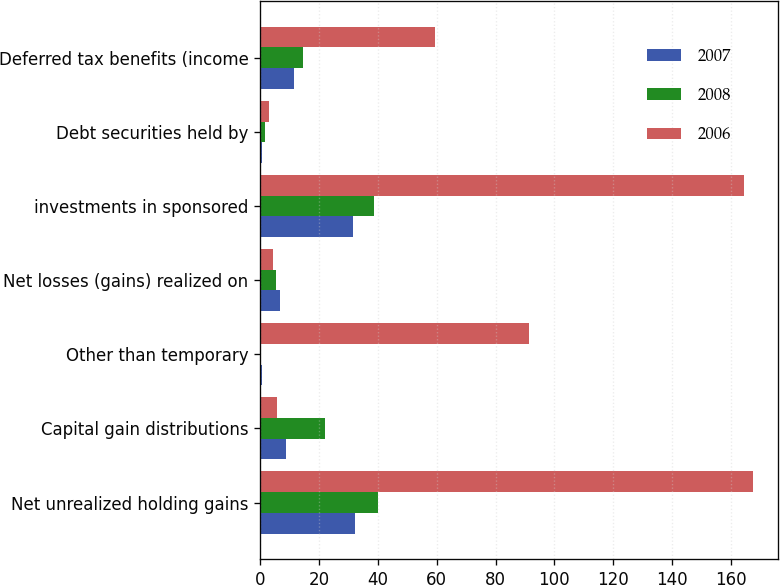Convert chart. <chart><loc_0><loc_0><loc_500><loc_500><stacked_bar_chart><ecel><fcel>Net unrealized holding gains<fcel>Capital gain distributions<fcel>Other than temporary<fcel>Net losses (gains) realized on<fcel>investments in sponsored<fcel>Debt securities held by<fcel>Deferred tax benefits (income<nl><fcel>2007<fcel>32.2<fcel>8.8<fcel>0.5<fcel>6.8<fcel>31.7<fcel>0.5<fcel>11.4<nl><fcel>2008<fcel>40.2<fcel>22.1<fcel>0.3<fcel>5.5<fcel>38.7<fcel>1.5<fcel>14.5<nl><fcel>2006<fcel>167.5<fcel>5.6<fcel>91.3<fcel>4.5<fcel>164.5<fcel>3<fcel>59.4<nl></chart> 